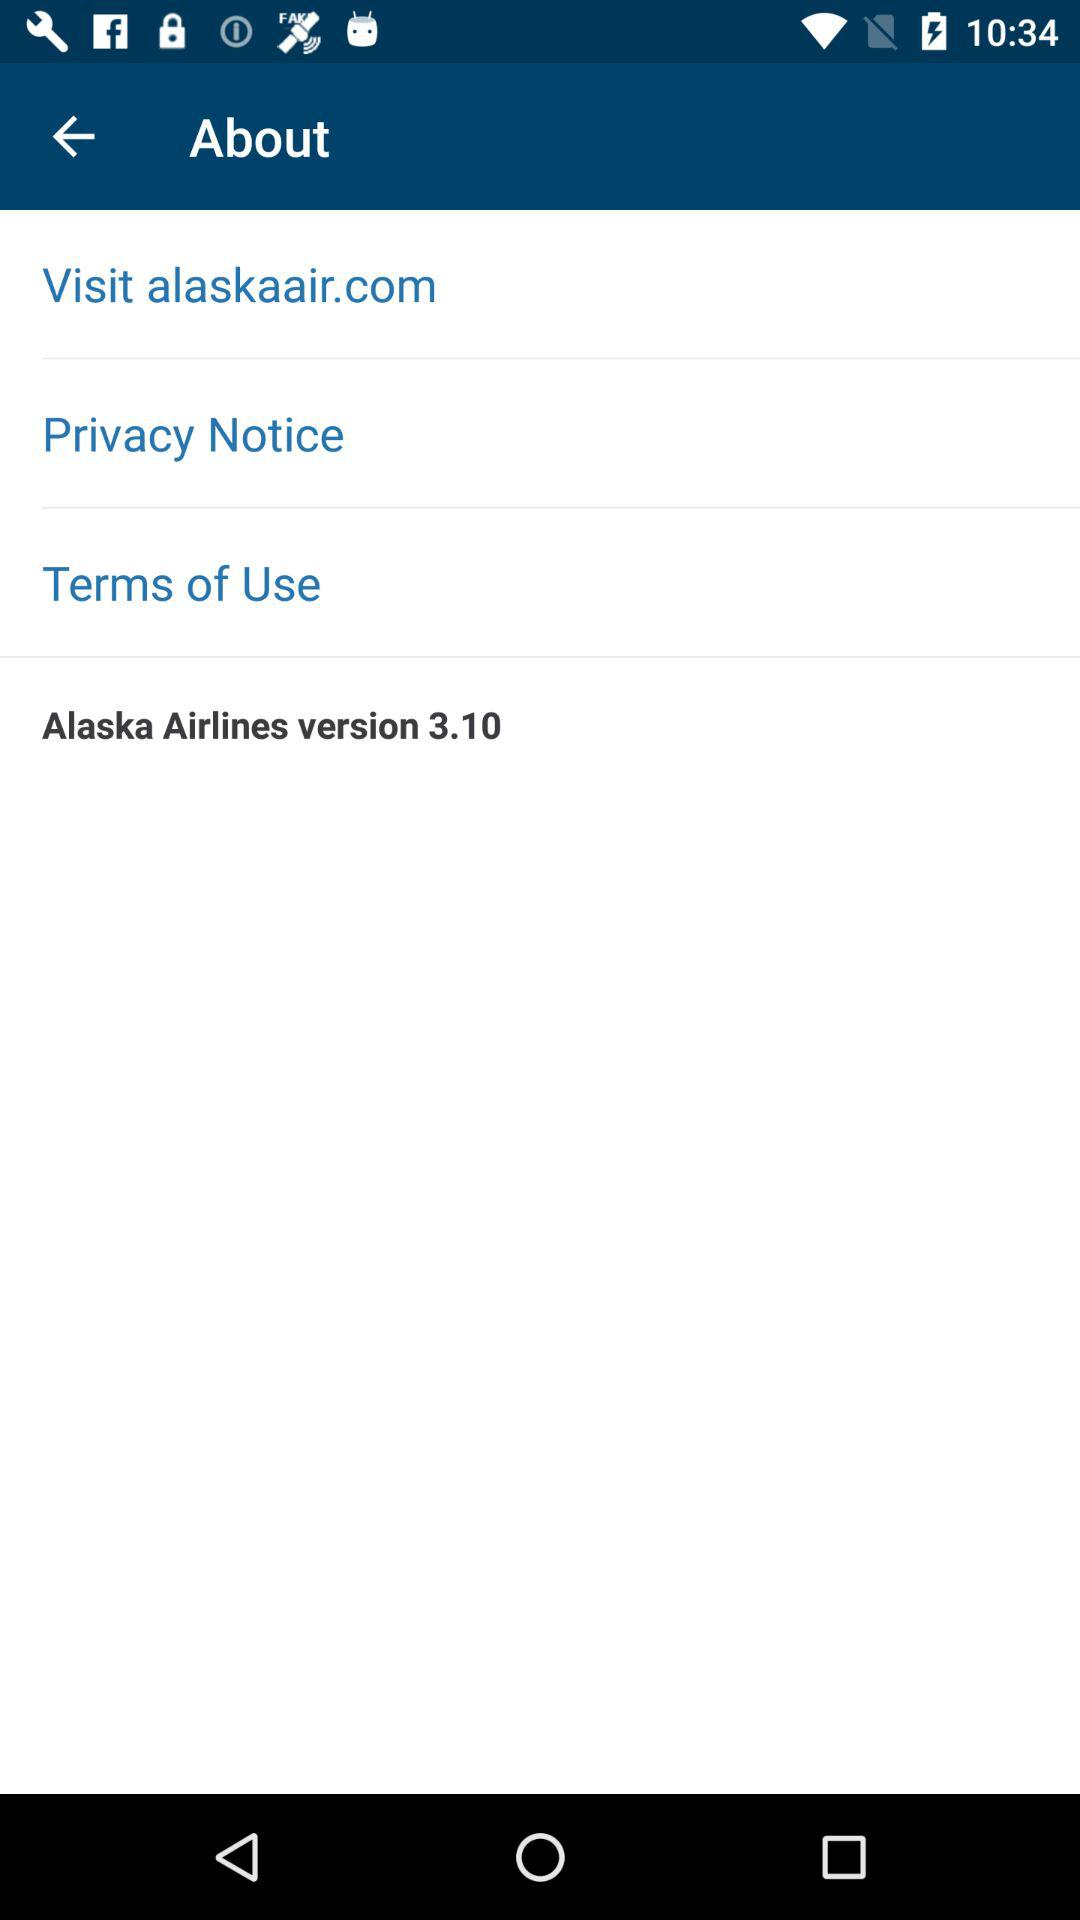What is the version of Alaska Airlines? The version of Alaska Airlines is 3.10. 